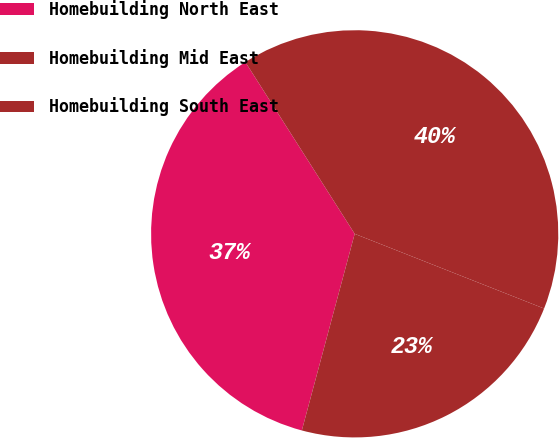Convert chart. <chart><loc_0><loc_0><loc_500><loc_500><pie_chart><fcel>Homebuilding North East<fcel>Homebuilding Mid East<fcel>Homebuilding South East<nl><fcel>36.8%<fcel>40.0%<fcel>23.2%<nl></chart> 